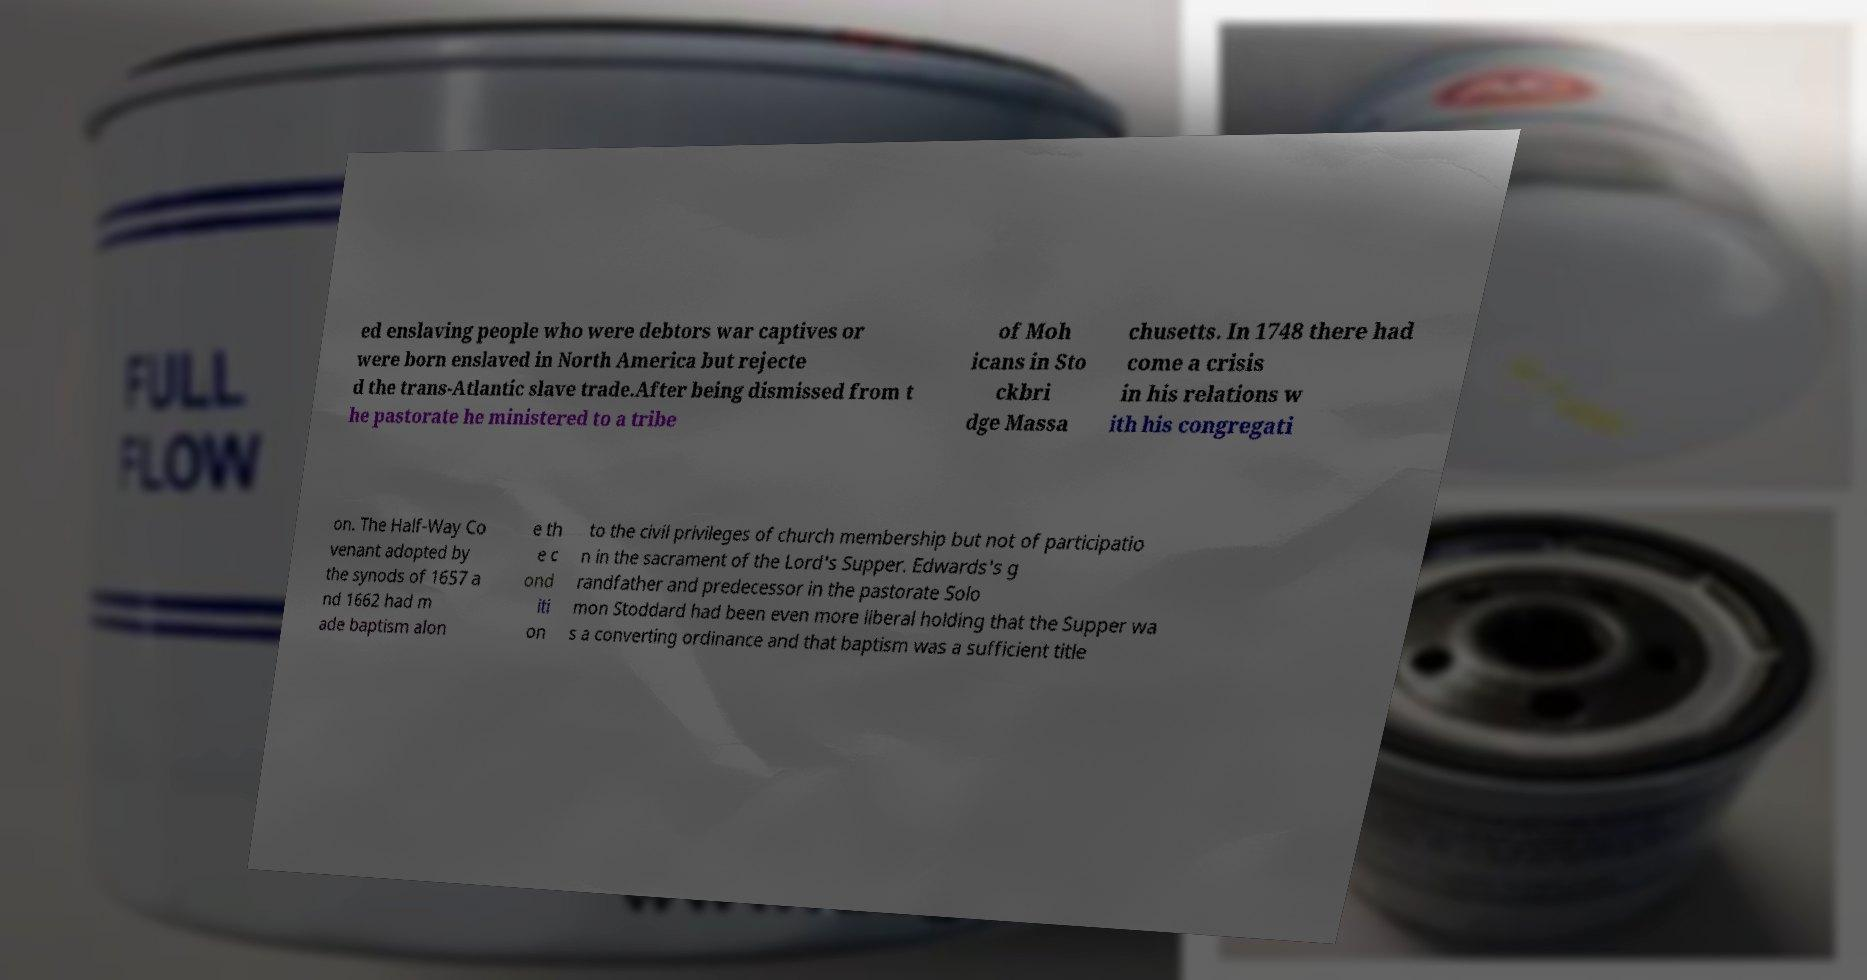For documentation purposes, I need the text within this image transcribed. Could you provide that? ed enslaving people who were debtors war captives or were born enslaved in North America but rejecte d the trans-Atlantic slave trade.After being dismissed from t he pastorate he ministered to a tribe of Moh icans in Sto ckbri dge Massa chusetts. In 1748 there had come a crisis in his relations w ith his congregati on. The Half-Way Co venant adopted by the synods of 1657 a nd 1662 had m ade baptism alon e th e c ond iti on to the civil privileges of church membership but not of participatio n in the sacrament of the Lord's Supper. Edwards's g randfather and predecessor in the pastorate Solo mon Stoddard had been even more liberal holding that the Supper wa s a converting ordinance and that baptism was a sufficient title 